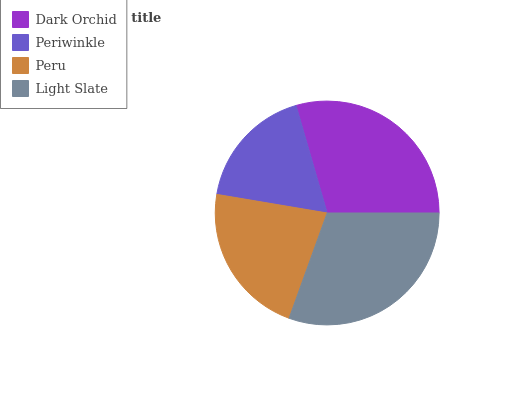Is Periwinkle the minimum?
Answer yes or no. Yes. Is Light Slate the maximum?
Answer yes or no. Yes. Is Peru the minimum?
Answer yes or no. No. Is Peru the maximum?
Answer yes or no. No. Is Peru greater than Periwinkle?
Answer yes or no. Yes. Is Periwinkle less than Peru?
Answer yes or no. Yes. Is Periwinkle greater than Peru?
Answer yes or no. No. Is Peru less than Periwinkle?
Answer yes or no. No. Is Dark Orchid the high median?
Answer yes or no. Yes. Is Peru the low median?
Answer yes or no. Yes. Is Light Slate the high median?
Answer yes or no. No. Is Dark Orchid the low median?
Answer yes or no. No. 